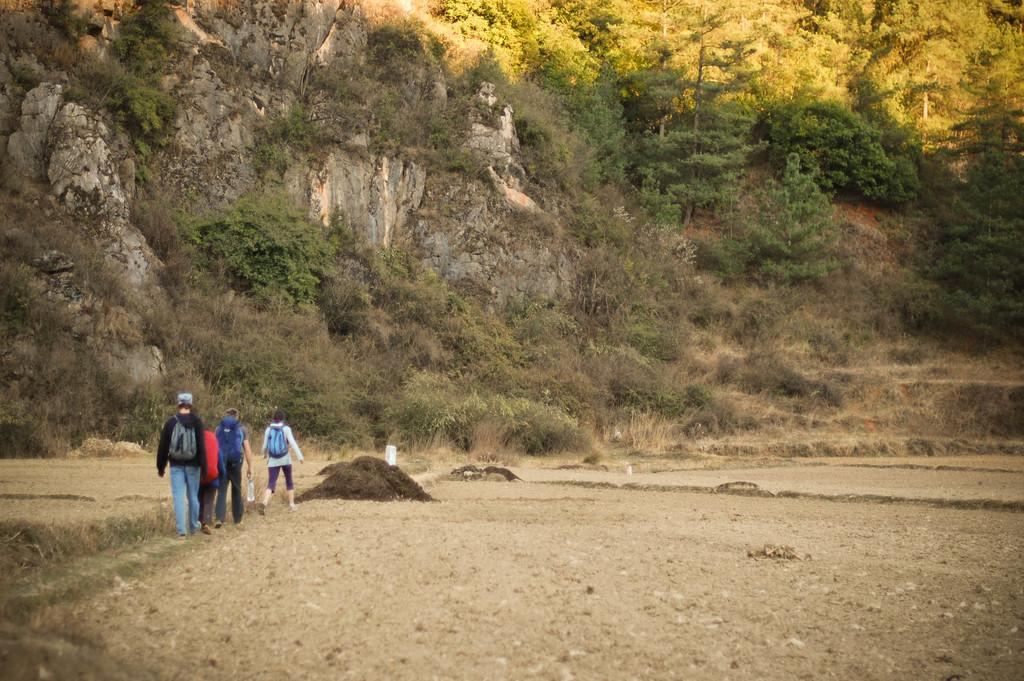How many objects or entities can be seen in the image? There are four objects or entities in the image. What can be seen in the background of the image? There are trees and plants in the background of the image. What page is the car turning to in the image? There is no car present in the image, so it is not possible to answer that question. 